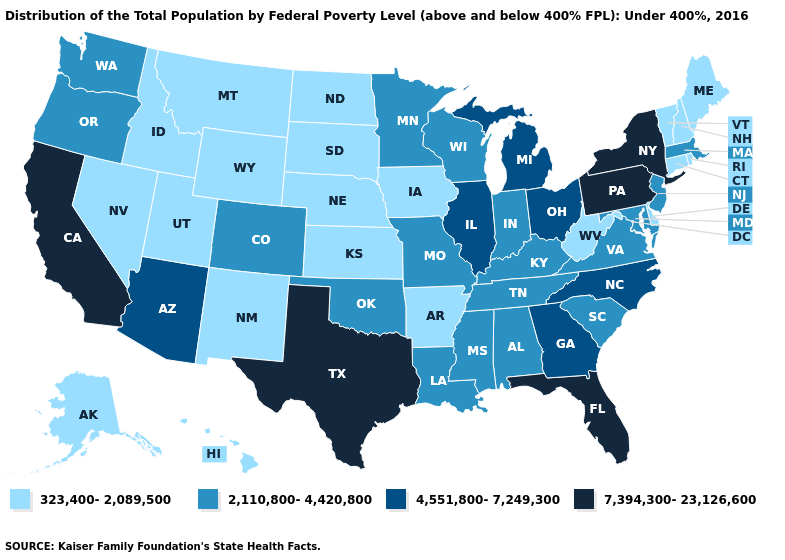What is the highest value in the West ?
Concise answer only. 7,394,300-23,126,600. Name the states that have a value in the range 4,551,800-7,249,300?
Answer briefly. Arizona, Georgia, Illinois, Michigan, North Carolina, Ohio. Which states have the lowest value in the South?
Give a very brief answer. Arkansas, Delaware, West Virginia. What is the value of Florida?
Keep it brief. 7,394,300-23,126,600. Does California have the highest value in the USA?
Short answer required. Yes. Does the map have missing data?
Answer briefly. No. What is the highest value in states that border Maine?
Concise answer only. 323,400-2,089,500. Which states hav the highest value in the West?
Concise answer only. California. Name the states that have a value in the range 4,551,800-7,249,300?
Answer briefly. Arizona, Georgia, Illinois, Michigan, North Carolina, Ohio. Which states have the highest value in the USA?
Quick response, please. California, Florida, New York, Pennsylvania, Texas. Among the states that border Washington , does Idaho have the highest value?
Short answer required. No. Name the states that have a value in the range 7,394,300-23,126,600?
Short answer required. California, Florida, New York, Pennsylvania, Texas. Is the legend a continuous bar?
Concise answer only. No. What is the lowest value in the USA?
Be succinct. 323,400-2,089,500. 